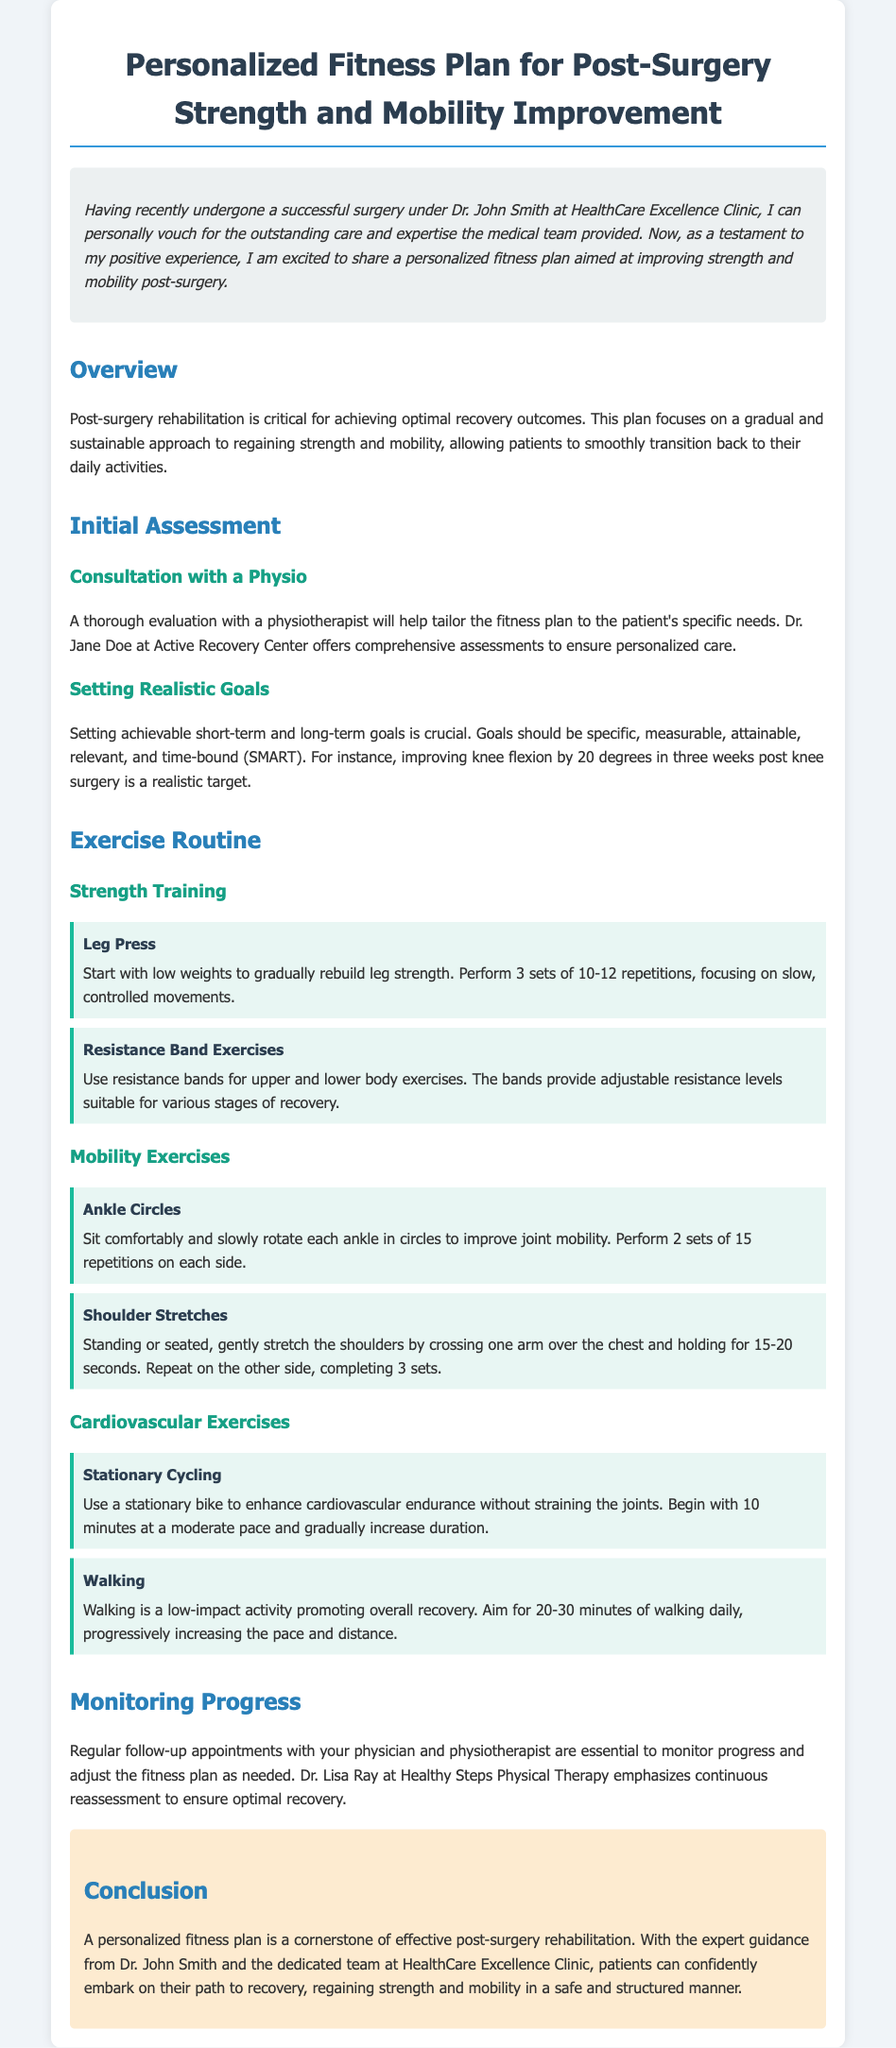What is the name of the medical surgeon mentioned in the document? The document mentions Dr. John Smith as the medical surgeon who performed the surgery.
Answer: Dr. John Smith What is the goal of setting realistic goals in the fitness plan? The document states that goals should be specific, measurable, attainable, relevant, and time-bound (SMART).
Answer: SMART How many repetitions are suggested for Leg Press exercises? The document specifies to perform 3 sets of 10-12 repetitions for Leg Press.
Answer: 10-12 Which type of exercise is advised for improving joint mobility? Ankle Circles are recommended to improve joint mobility.
Answer: Ankle Circles What is the recommended duration for stationary cycling to start? The document suggests beginning stationary cycling with 10 minutes at a moderate pace.
Answer: 10 minutes How important are follow-up appointments according to the document? The document emphasizes that regular follow-up appointments are essential to monitor progress and adjust the fitness plan.
Answer: Essential What center does Dr. Jane Doe belong to? Dr. Jane Doe is associated with Active Recovery Center, where comprehensive assessments are offered.
Answer: Active Recovery Center What is the background color of the introduction section? The introduction section has a background color of #ecf0f1.
Answer: #ecf0f1 What is one of the main benefits of the personalized fitness plan? The document states that a personalized fitness plan helps patients regain strength and mobility in a safe and structured manner.
Answer: Regain strength and mobility 